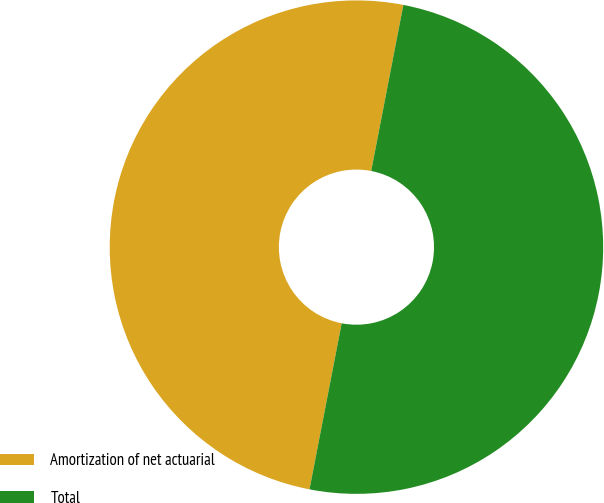Convert chart. <chart><loc_0><loc_0><loc_500><loc_500><pie_chart><fcel>Amortization of net actuarial<fcel>Total<nl><fcel>50.0%<fcel>50.0%<nl></chart> 